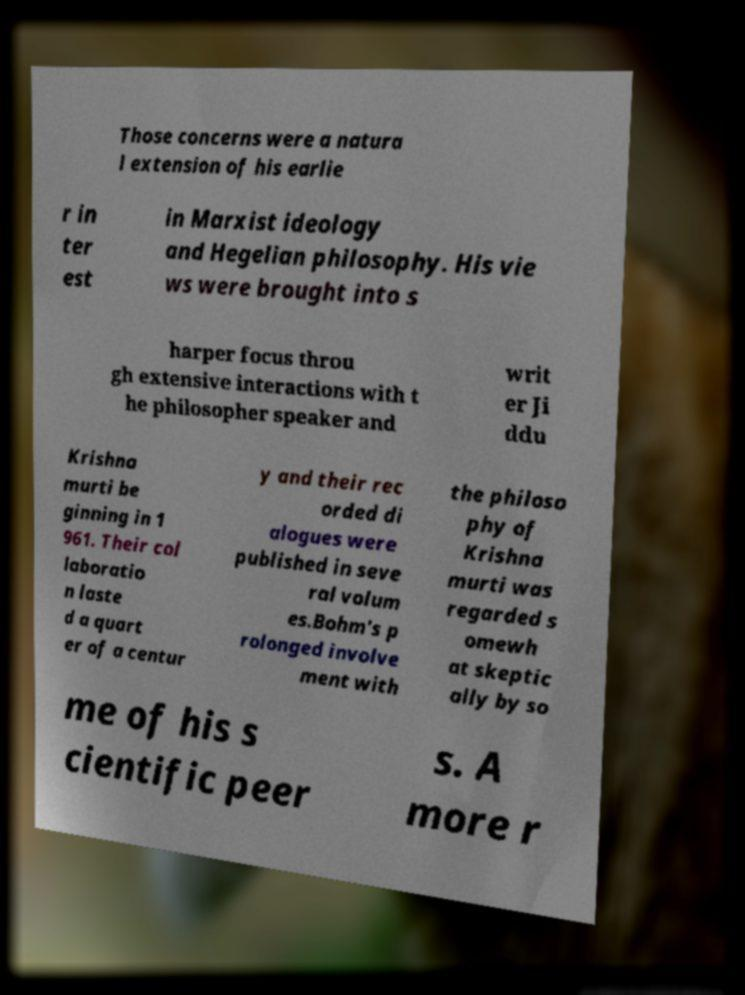Please identify and transcribe the text found in this image. Those concerns were a natura l extension of his earlie r in ter est in Marxist ideology and Hegelian philosophy. His vie ws were brought into s harper focus throu gh extensive interactions with t he philosopher speaker and writ er Ji ddu Krishna murti be ginning in 1 961. Their col laboratio n laste d a quart er of a centur y and their rec orded di alogues were published in seve ral volum es.Bohm's p rolonged involve ment with the philoso phy of Krishna murti was regarded s omewh at skeptic ally by so me of his s cientific peer s. A more r 